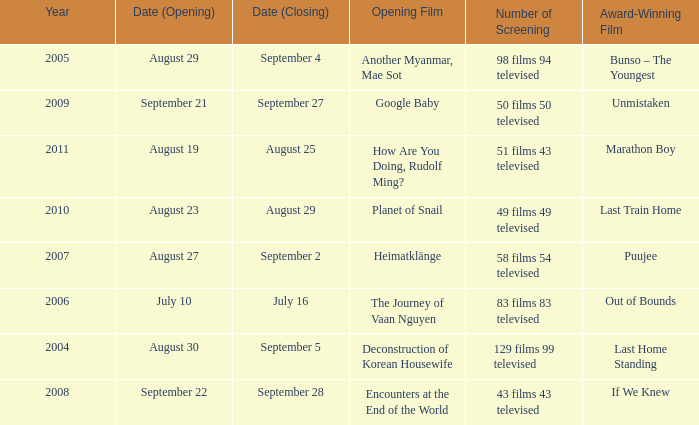How many number of screenings have an opening film of the journey of vaan nguyen? 1.0. 